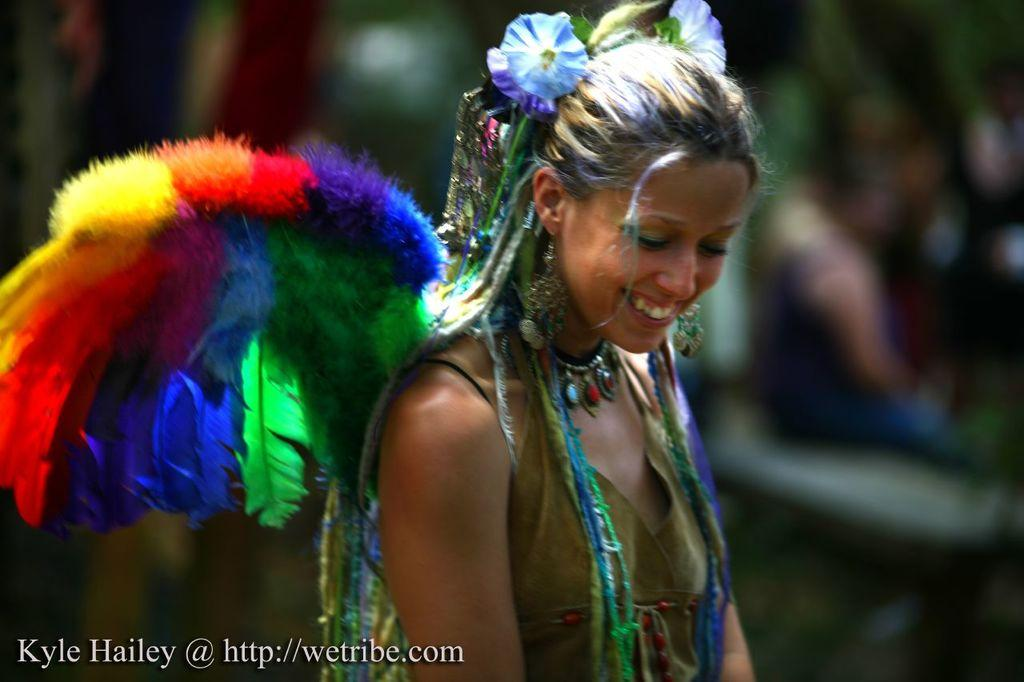Who is the main subject in the image? There is a lady in the center of the image. What is the lady doing in the image? The lady is smiling. What is the lady wearing in the image? The lady is wearing a costume. What can be found in the bottom left corner of the image? There is some text in the bottom left corner of the image. How would you describe the background of the image? The background of the image is blurry. What shape is the lady's guide in the image? There is no guide present in the image, so it is not possible to determine its shape. 